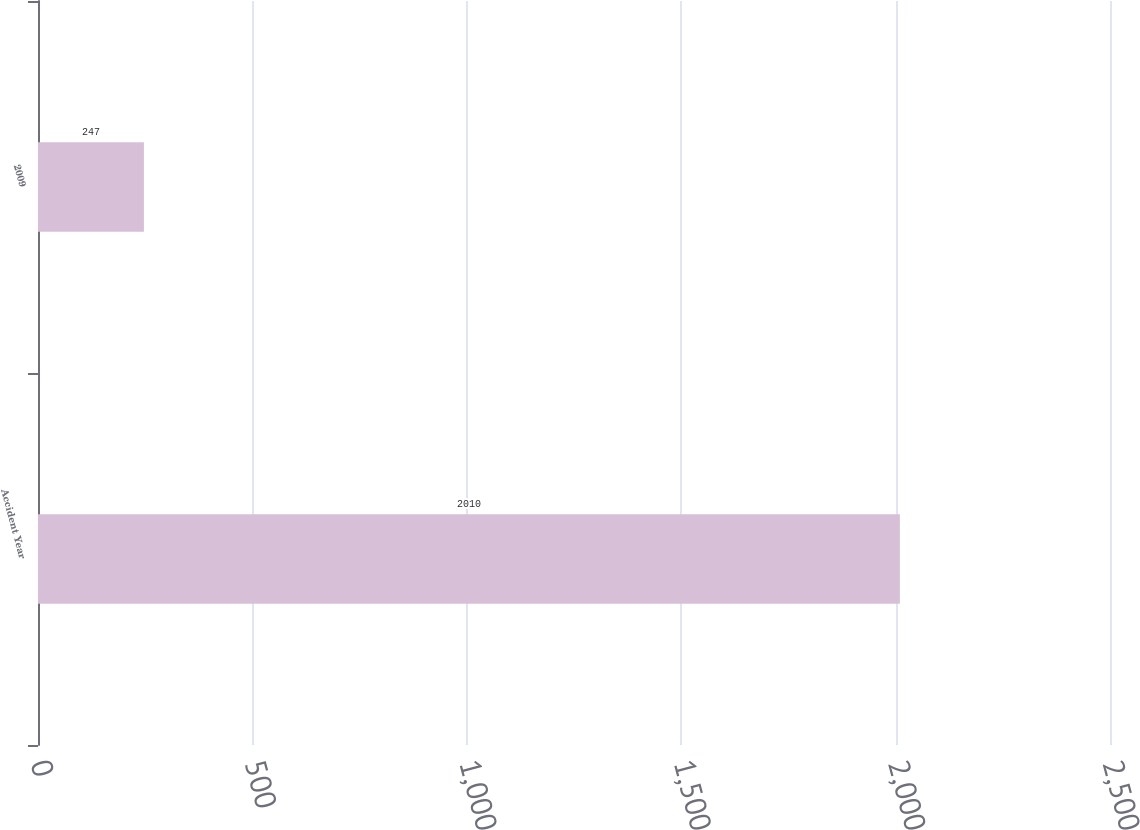Convert chart. <chart><loc_0><loc_0><loc_500><loc_500><bar_chart><fcel>Accident Year<fcel>2009<nl><fcel>2010<fcel>247<nl></chart> 